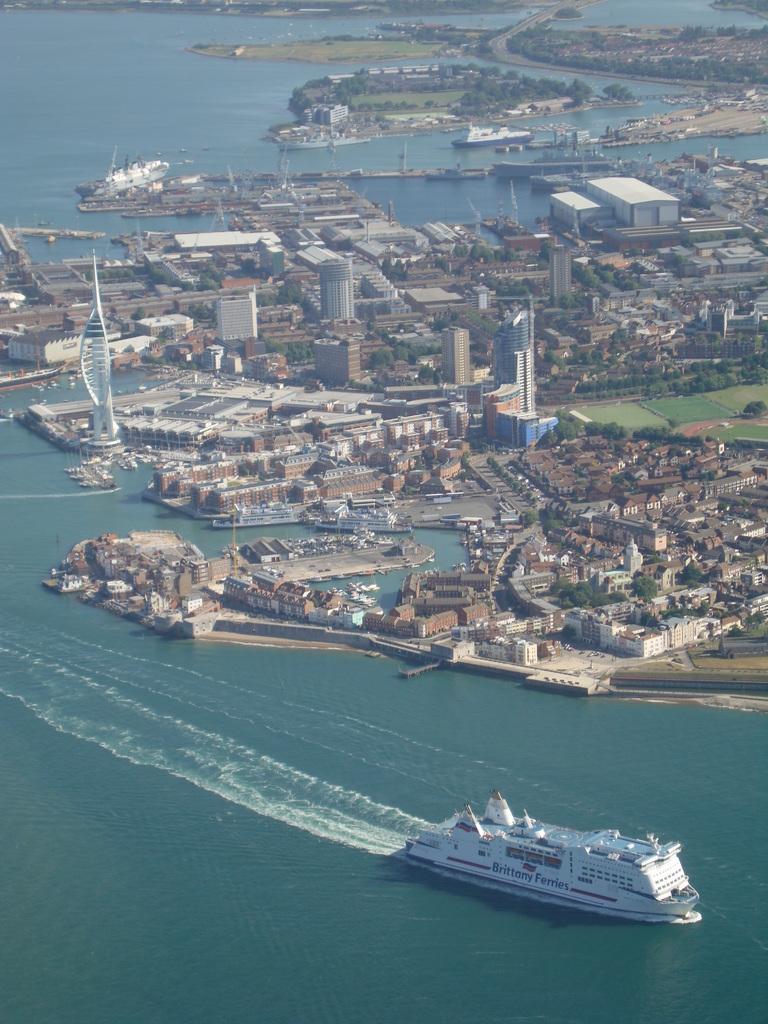In one or two sentences, can you explain what this image depicts? In this image I can see ships on the water beside that there are so many buildings and trees on the ground. 